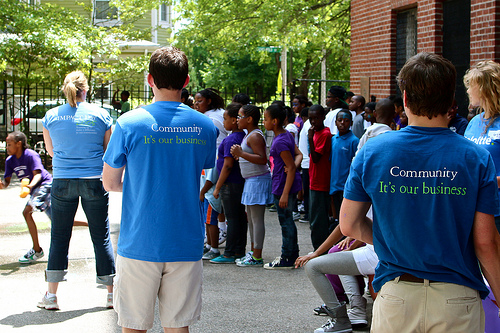<image>
Can you confirm if the man is behind the woman? Yes. From this viewpoint, the man is positioned behind the woman, with the woman partially or fully occluding the man. Where is the man in relation to the woman? Is it in front of the woman? Yes. The man is positioned in front of the woman, appearing closer to the camera viewpoint. 